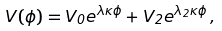<formula> <loc_0><loc_0><loc_500><loc_500>V ( \phi ) = V _ { 0 } e ^ { \lambda \kappa \phi } + V _ { 2 } e ^ { \lambda _ { 2 } \kappa \phi } \, ,</formula> 